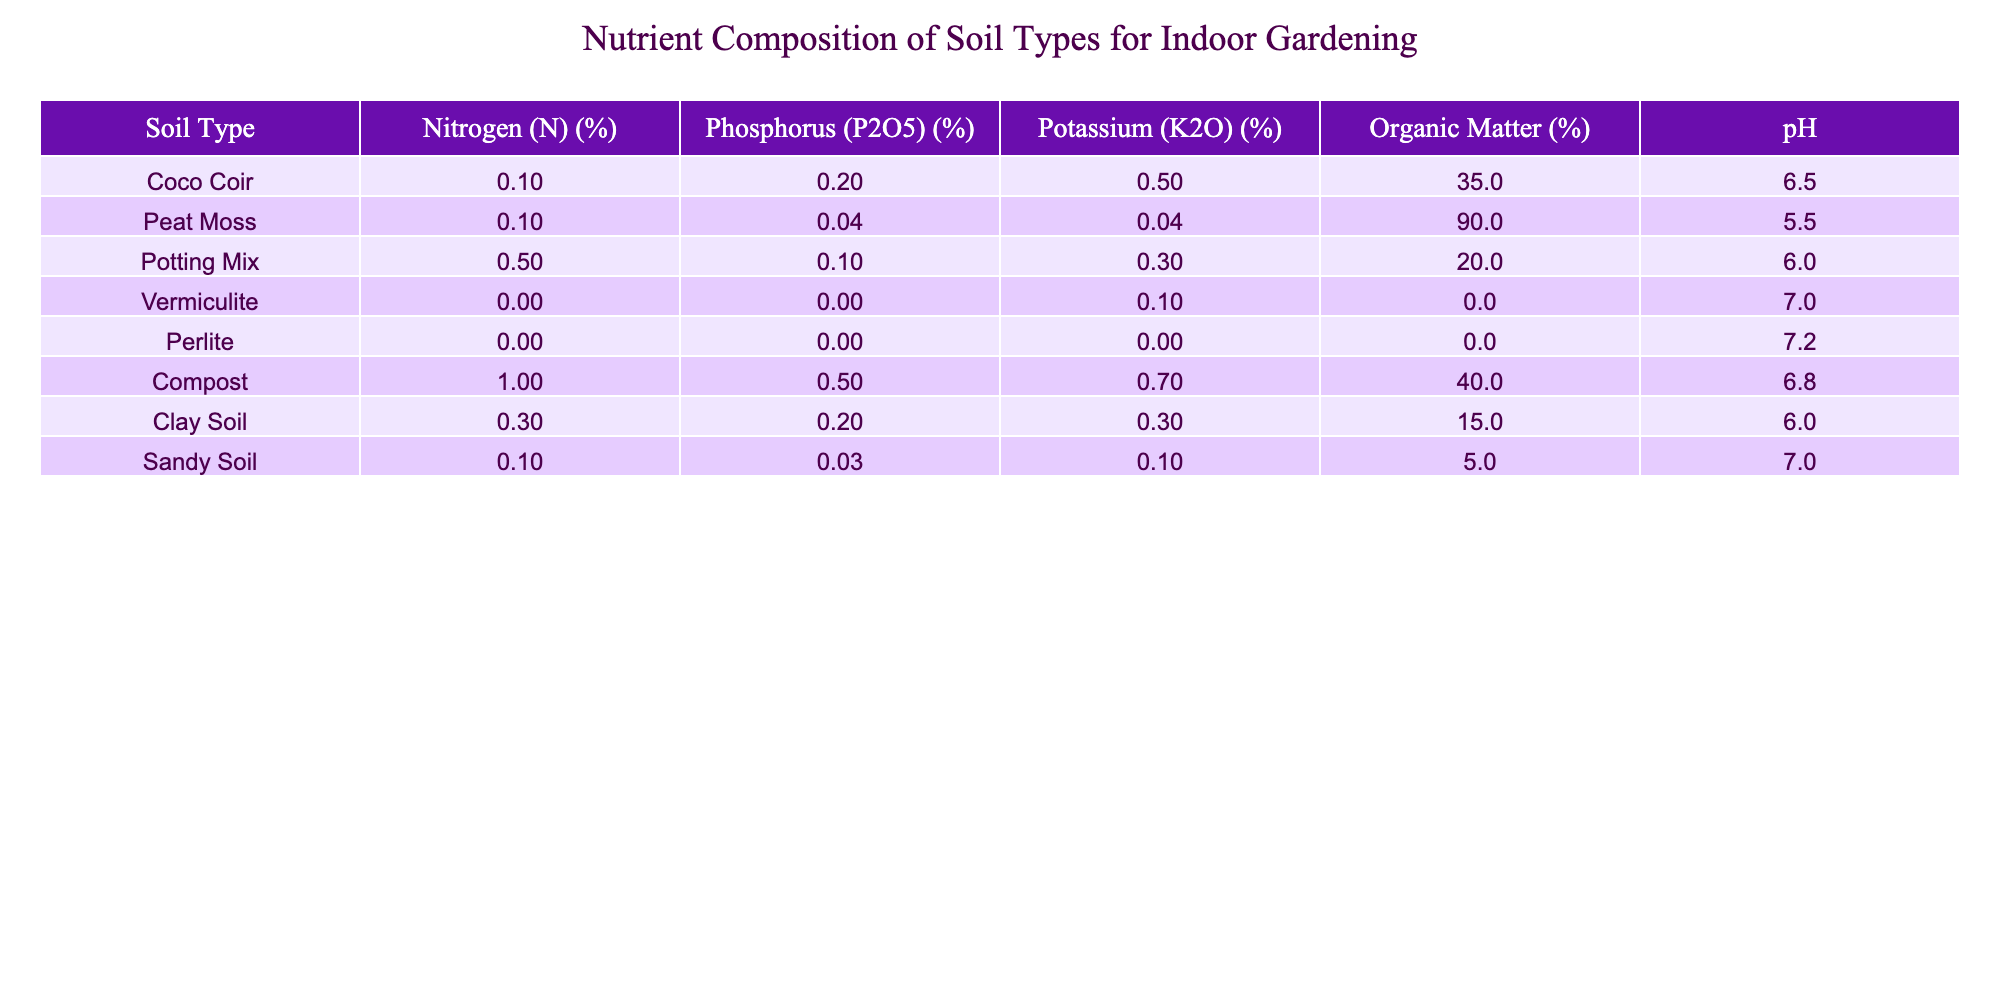What is the nitrogen content in Compost? According to the table, the nitrogen content in Compost is 1.0%.
Answer: 1.0% Which soil type has the highest organic matter percentage? The table shows that Peat Moss has the highest organic matter percentage at 90%.
Answer: Peat Moss What is the average phosphorus percentage across all soil types? To find the average, sum the phosphorus values: (0.2 + 0.04 + 0.1 + 0 + 0 + 0.5 + 0.2 + 0.03) = 1.12%. There are 8 soil types, so average is 1.12% / 8 = 0.14%.
Answer: 0.14% Does any soil type have a potassium percentage of zero? Yes, according to the table, both Perlite and Vermiculite have a potassium percentage of 0.
Answer: Yes Which soil type has the highest pH value? By looking at the table, Perlite has the highest pH value at 7.2.
Answer: Perlite What is the difference in nitrogen content between Potting Mix and Clay Soil? The nitrogen content in Potting Mix is 0.5% and in Clay Soil is 0.3%. The difference is 0.5% - 0.3% = 0.2%.
Answer: 0.2% Is the organic matter percentage in Coco Coir greater than that in Sandy Soil? From the table, Coco Coir has 35% organic matter while Sandy Soil has 5%. Since 35% is greater than 5%, the statement is true.
Answer: Yes Which soil type has the lowest potassium content? The table indicates that both Vermiculite and Perlite have a potassium content of 0%, which is the lowest among all soil types.
Answer: Vermiculite and Perlite What is the total potassium content of Compost and Potting Mix combined? The potassium content in Compost is 0.7% and in Potting Mix is 0.3%. Therefore, the total is 0.7% + 0.3% = 1.0%.
Answer: 1.0% 